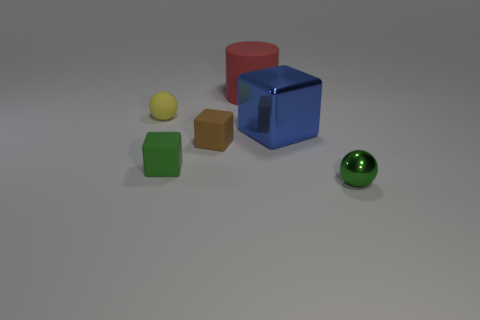Add 3 cyan balls. How many objects exist? 9 Subtract all balls. How many objects are left? 4 Add 3 large red cylinders. How many large red cylinders are left? 4 Add 4 large blue cubes. How many large blue cubes exist? 5 Subtract 1 brown cubes. How many objects are left? 5 Subtract all green cubes. Subtract all tiny red matte cubes. How many objects are left? 5 